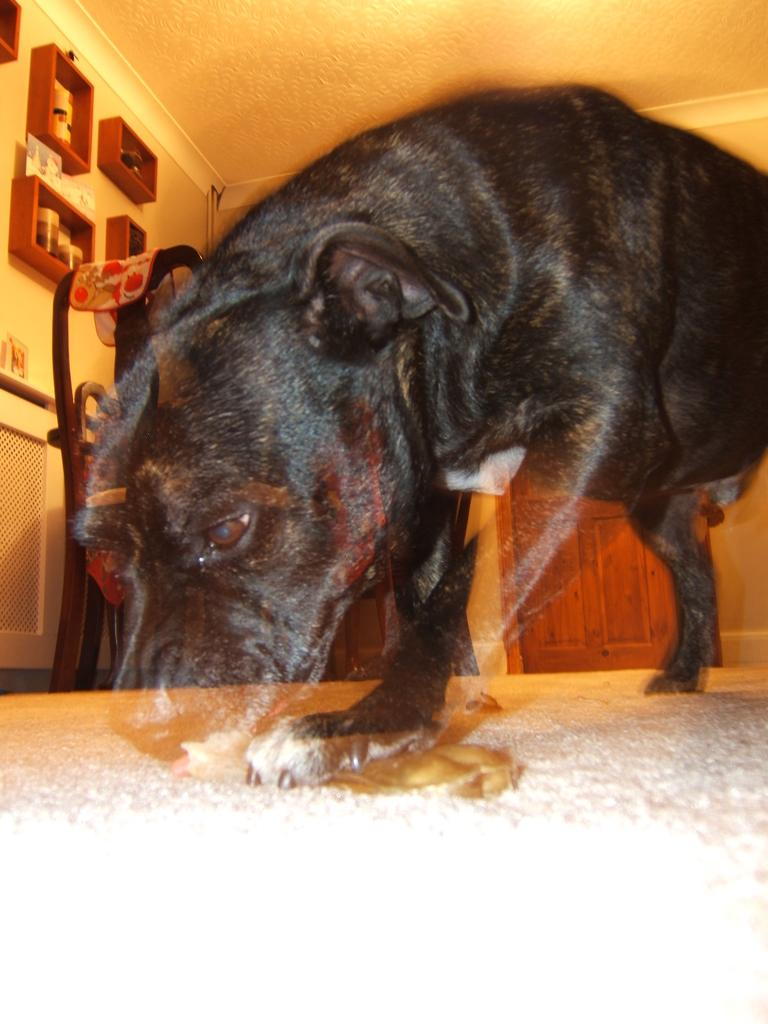What type of animal is in the image? There is a dog in the image. What color is the dog? The dog is black. What can be seen in the background of the image? There are bottles in a rack in the background. What is the color of the door in the image? The door is brown. What color is the wall in the image? The wall is cream-colored. How much income does the dog generate in the image? There is no information about the dog's income in the image. Additionally, dogs do not generate income. 